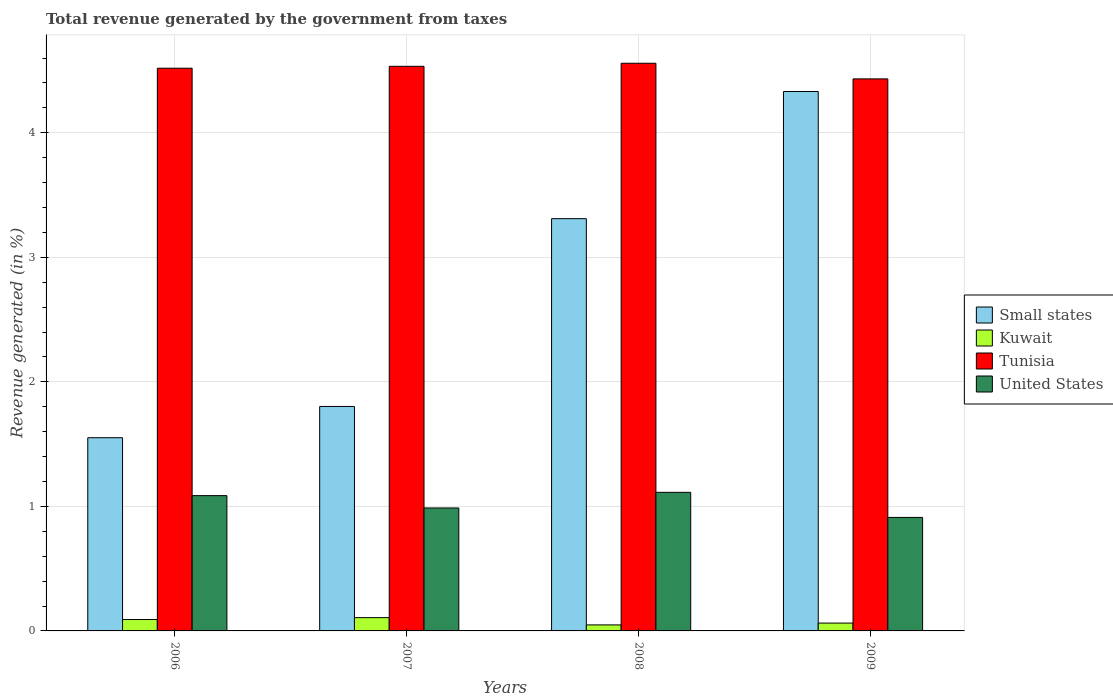How many different coloured bars are there?
Keep it short and to the point. 4. How many groups of bars are there?
Your response must be concise. 4. How many bars are there on the 4th tick from the left?
Your answer should be compact. 4. How many bars are there on the 4th tick from the right?
Give a very brief answer. 4. In how many cases, is the number of bars for a given year not equal to the number of legend labels?
Your answer should be compact. 0. What is the total revenue generated in Kuwait in 2007?
Your answer should be very brief. 0.11. Across all years, what is the maximum total revenue generated in Tunisia?
Make the answer very short. 4.56. Across all years, what is the minimum total revenue generated in United States?
Offer a very short reply. 0.91. In which year was the total revenue generated in Small states maximum?
Your answer should be very brief. 2009. In which year was the total revenue generated in Tunisia minimum?
Your answer should be compact. 2009. What is the total total revenue generated in Kuwait in the graph?
Make the answer very short. 0.31. What is the difference between the total revenue generated in Small states in 2006 and that in 2007?
Give a very brief answer. -0.25. What is the difference between the total revenue generated in Small states in 2007 and the total revenue generated in Kuwait in 2006?
Make the answer very short. 1.71. What is the average total revenue generated in Kuwait per year?
Give a very brief answer. 0.08. In the year 2008, what is the difference between the total revenue generated in Tunisia and total revenue generated in Kuwait?
Provide a succinct answer. 4.51. In how many years, is the total revenue generated in United States greater than 2.2 %?
Your response must be concise. 0. What is the ratio of the total revenue generated in United States in 2008 to that in 2009?
Give a very brief answer. 1.22. Is the total revenue generated in Small states in 2006 less than that in 2007?
Provide a short and direct response. Yes. What is the difference between the highest and the second highest total revenue generated in United States?
Keep it short and to the point. 0.03. What is the difference between the highest and the lowest total revenue generated in Tunisia?
Ensure brevity in your answer.  0.13. In how many years, is the total revenue generated in Tunisia greater than the average total revenue generated in Tunisia taken over all years?
Provide a succinct answer. 3. Is the sum of the total revenue generated in United States in 2007 and 2008 greater than the maximum total revenue generated in Small states across all years?
Your response must be concise. No. Is it the case that in every year, the sum of the total revenue generated in Kuwait and total revenue generated in United States is greater than the sum of total revenue generated in Small states and total revenue generated in Tunisia?
Give a very brief answer. Yes. What does the 3rd bar from the left in 2008 represents?
Your answer should be very brief. Tunisia. What does the 3rd bar from the right in 2007 represents?
Provide a short and direct response. Kuwait. How many bars are there?
Provide a succinct answer. 16. What is the difference between two consecutive major ticks on the Y-axis?
Your answer should be very brief. 1. Are the values on the major ticks of Y-axis written in scientific E-notation?
Offer a very short reply. No. How are the legend labels stacked?
Offer a terse response. Vertical. What is the title of the graph?
Ensure brevity in your answer.  Total revenue generated by the government from taxes. What is the label or title of the X-axis?
Give a very brief answer. Years. What is the label or title of the Y-axis?
Your answer should be very brief. Revenue generated (in %). What is the Revenue generated (in %) of Small states in 2006?
Keep it short and to the point. 1.55. What is the Revenue generated (in %) in Kuwait in 2006?
Your answer should be very brief. 0.09. What is the Revenue generated (in %) of Tunisia in 2006?
Your answer should be very brief. 4.52. What is the Revenue generated (in %) of United States in 2006?
Provide a succinct answer. 1.09. What is the Revenue generated (in %) in Small states in 2007?
Your answer should be very brief. 1.8. What is the Revenue generated (in %) of Kuwait in 2007?
Keep it short and to the point. 0.11. What is the Revenue generated (in %) in Tunisia in 2007?
Your answer should be compact. 4.53. What is the Revenue generated (in %) of United States in 2007?
Provide a short and direct response. 0.99. What is the Revenue generated (in %) in Small states in 2008?
Give a very brief answer. 3.31. What is the Revenue generated (in %) in Kuwait in 2008?
Make the answer very short. 0.05. What is the Revenue generated (in %) in Tunisia in 2008?
Offer a very short reply. 4.56. What is the Revenue generated (in %) in United States in 2008?
Offer a very short reply. 1.11. What is the Revenue generated (in %) of Small states in 2009?
Provide a short and direct response. 4.33. What is the Revenue generated (in %) in Kuwait in 2009?
Ensure brevity in your answer.  0.06. What is the Revenue generated (in %) of Tunisia in 2009?
Make the answer very short. 4.43. What is the Revenue generated (in %) in United States in 2009?
Provide a succinct answer. 0.91. Across all years, what is the maximum Revenue generated (in %) of Small states?
Your response must be concise. 4.33. Across all years, what is the maximum Revenue generated (in %) in Kuwait?
Keep it short and to the point. 0.11. Across all years, what is the maximum Revenue generated (in %) in Tunisia?
Your answer should be compact. 4.56. Across all years, what is the maximum Revenue generated (in %) in United States?
Ensure brevity in your answer.  1.11. Across all years, what is the minimum Revenue generated (in %) in Small states?
Offer a terse response. 1.55. Across all years, what is the minimum Revenue generated (in %) in Kuwait?
Your response must be concise. 0.05. Across all years, what is the minimum Revenue generated (in %) of Tunisia?
Ensure brevity in your answer.  4.43. Across all years, what is the minimum Revenue generated (in %) in United States?
Ensure brevity in your answer.  0.91. What is the total Revenue generated (in %) in Small states in the graph?
Provide a short and direct response. 10.99. What is the total Revenue generated (in %) in Kuwait in the graph?
Give a very brief answer. 0.31. What is the total Revenue generated (in %) in Tunisia in the graph?
Your answer should be very brief. 18.04. What is the total Revenue generated (in %) of United States in the graph?
Keep it short and to the point. 4.1. What is the difference between the Revenue generated (in %) of Small states in 2006 and that in 2007?
Ensure brevity in your answer.  -0.25. What is the difference between the Revenue generated (in %) in Kuwait in 2006 and that in 2007?
Give a very brief answer. -0.02. What is the difference between the Revenue generated (in %) of Tunisia in 2006 and that in 2007?
Your response must be concise. -0.02. What is the difference between the Revenue generated (in %) in United States in 2006 and that in 2007?
Offer a terse response. 0.1. What is the difference between the Revenue generated (in %) of Small states in 2006 and that in 2008?
Keep it short and to the point. -1.76. What is the difference between the Revenue generated (in %) of Kuwait in 2006 and that in 2008?
Ensure brevity in your answer.  0.04. What is the difference between the Revenue generated (in %) in Tunisia in 2006 and that in 2008?
Provide a short and direct response. -0.04. What is the difference between the Revenue generated (in %) of United States in 2006 and that in 2008?
Your response must be concise. -0.03. What is the difference between the Revenue generated (in %) in Small states in 2006 and that in 2009?
Offer a very short reply. -2.78. What is the difference between the Revenue generated (in %) of Kuwait in 2006 and that in 2009?
Your answer should be very brief. 0.03. What is the difference between the Revenue generated (in %) of Tunisia in 2006 and that in 2009?
Your response must be concise. 0.09. What is the difference between the Revenue generated (in %) in United States in 2006 and that in 2009?
Offer a very short reply. 0.17. What is the difference between the Revenue generated (in %) of Small states in 2007 and that in 2008?
Keep it short and to the point. -1.51. What is the difference between the Revenue generated (in %) of Kuwait in 2007 and that in 2008?
Ensure brevity in your answer.  0.06. What is the difference between the Revenue generated (in %) of Tunisia in 2007 and that in 2008?
Provide a short and direct response. -0.02. What is the difference between the Revenue generated (in %) of United States in 2007 and that in 2008?
Ensure brevity in your answer.  -0.13. What is the difference between the Revenue generated (in %) in Small states in 2007 and that in 2009?
Keep it short and to the point. -2.53. What is the difference between the Revenue generated (in %) in Kuwait in 2007 and that in 2009?
Keep it short and to the point. 0.04. What is the difference between the Revenue generated (in %) in Tunisia in 2007 and that in 2009?
Offer a very short reply. 0.1. What is the difference between the Revenue generated (in %) of United States in 2007 and that in 2009?
Offer a terse response. 0.08. What is the difference between the Revenue generated (in %) in Small states in 2008 and that in 2009?
Ensure brevity in your answer.  -1.02. What is the difference between the Revenue generated (in %) in Kuwait in 2008 and that in 2009?
Your response must be concise. -0.01. What is the difference between the Revenue generated (in %) in Tunisia in 2008 and that in 2009?
Provide a short and direct response. 0.13. What is the difference between the Revenue generated (in %) in United States in 2008 and that in 2009?
Provide a succinct answer. 0.2. What is the difference between the Revenue generated (in %) of Small states in 2006 and the Revenue generated (in %) of Kuwait in 2007?
Ensure brevity in your answer.  1.44. What is the difference between the Revenue generated (in %) in Small states in 2006 and the Revenue generated (in %) in Tunisia in 2007?
Your answer should be very brief. -2.98. What is the difference between the Revenue generated (in %) in Small states in 2006 and the Revenue generated (in %) in United States in 2007?
Provide a short and direct response. 0.56. What is the difference between the Revenue generated (in %) in Kuwait in 2006 and the Revenue generated (in %) in Tunisia in 2007?
Ensure brevity in your answer.  -4.44. What is the difference between the Revenue generated (in %) in Kuwait in 2006 and the Revenue generated (in %) in United States in 2007?
Your response must be concise. -0.9. What is the difference between the Revenue generated (in %) of Tunisia in 2006 and the Revenue generated (in %) of United States in 2007?
Offer a very short reply. 3.53. What is the difference between the Revenue generated (in %) in Small states in 2006 and the Revenue generated (in %) in Kuwait in 2008?
Give a very brief answer. 1.5. What is the difference between the Revenue generated (in %) of Small states in 2006 and the Revenue generated (in %) of Tunisia in 2008?
Provide a short and direct response. -3.01. What is the difference between the Revenue generated (in %) in Small states in 2006 and the Revenue generated (in %) in United States in 2008?
Ensure brevity in your answer.  0.44. What is the difference between the Revenue generated (in %) of Kuwait in 2006 and the Revenue generated (in %) of Tunisia in 2008?
Provide a succinct answer. -4.47. What is the difference between the Revenue generated (in %) in Kuwait in 2006 and the Revenue generated (in %) in United States in 2008?
Offer a very short reply. -1.02. What is the difference between the Revenue generated (in %) of Tunisia in 2006 and the Revenue generated (in %) of United States in 2008?
Provide a short and direct response. 3.41. What is the difference between the Revenue generated (in %) in Small states in 2006 and the Revenue generated (in %) in Kuwait in 2009?
Your answer should be compact. 1.49. What is the difference between the Revenue generated (in %) of Small states in 2006 and the Revenue generated (in %) of Tunisia in 2009?
Make the answer very short. -2.88. What is the difference between the Revenue generated (in %) in Small states in 2006 and the Revenue generated (in %) in United States in 2009?
Your answer should be compact. 0.64. What is the difference between the Revenue generated (in %) in Kuwait in 2006 and the Revenue generated (in %) in Tunisia in 2009?
Offer a very short reply. -4.34. What is the difference between the Revenue generated (in %) in Kuwait in 2006 and the Revenue generated (in %) in United States in 2009?
Your response must be concise. -0.82. What is the difference between the Revenue generated (in %) in Tunisia in 2006 and the Revenue generated (in %) in United States in 2009?
Give a very brief answer. 3.61. What is the difference between the Revenue generated (in %) in Small states in 2007 and the Revenue generated (in %) in Kuwait in 2008?
Your answer should be compact. 1.75. What is the difference between the Revenue generated (in %) in Small states in 2007 and the Revenue generated (in %) in Tunisia in 2008?
Your response must be concise. -2.76. What is the difference between the Revenue generated (in %) in Small states in 2007 and the Revenue generated (in %) in United States in 2008?
Your answer should be compact. 0.69. What is the difference between the Revenue generated (in %) of Kuwait in 2007 and the Revenue generated (in %) of Tunisia in 2008?
Your answer should be very brief. -4.45. What is the difference between the Revenue generated (in %) in Kuwait in 2007 and the Revenue generated (in %) in United States in 2008?
Ensure brevity in your answer.  -1.01. What is the difference between the Revenue generated (in %) of Tunisia in 2007 and the Revenue generated (in %) of United States in 2008?
Offer a very short reply. 3.42. What is the difference between the Revenue generated (in %) in Small states in 2007 and the Revenue generated (in %) in Kuwait in 2009?
Ensure brevity in your answer.  1.74. What is the difference between the Revenue generated (in %) of Small states in 2007 and the Revenue generated (in %) of Tunisia in 2009?
Your response must be concise. -2.63. What is the difference between the Revenue generated (in %) in Small states in 2007 and the Revenue generated (in %) in United States in 2009?
Your answer should be compact. 0.89. What is the difference between the Revenue generated (in %) of Kuwait in 2007 and the Revenue generated (in %) of Tunisia in 2009?
Provide a short and direct response. -4.33. What is the difference between the Revenue generated (in %) in Kuwait in 2007 and the Revenue generated (in %) in United States in 2009?
Provide a succinct answer. -0.8. What is the difference between the Revenue generated (in %) of Tunisia in 2007 and the Revenue generated (in %) of United States in 2009?
Your answer should be compact. 3.62. What is the difference between the Revenue generated (in %) in Small states in 2008 and the Revenue generated (in %) in Kuwait in 2009?
Offer a terse response. 3.25. What is the difference between the Revenue generated (in %) in Small states in 2008 and the Revenue generated (in %) in Tunisia in 2009?
Your response must be concise. -1.12. What is the difference between the Revenue generated (in %) of Small states in 2008 and the Revenue generated (in %) of United States in 2009?
Your answer should be very brief. 2.4. What is the difference between the Revenue generated (in %) in Kuwait in 2008 and the Revenue generated (in %) in Tunisia in 2009?
Your response must be concise. -4.38. What is the difference between the Revenue generated (in %) in Kuwait in 2008 and the Revenue generated (in %) in United States in 2009?
Offer a terse response. -0.86. What is the difference between the Revenue generated (in %) in Tunisia in 2008 and the Revenue generated (in %) in United States in 2009?
Give a very brief answer. 3.65. What is the average Revenue generated (in %) of Small states per year?
Your answer should be compact. 2.75. What is the average Revenue generated (in %) in Kuwait per year?
Ensure brevity in your answer.  0.08. What is the average Revenue generated (in %) in Tunisia per year?
Your answer should be compact. 4.51. What is the average Revenue generated (in %) in United States per year?
Offer a terse response. 1.02. In the year 2006, what is the difference between the Revenue generated (in %) of Small states and Revenue generated (in %) of Kuwait?
Your answer should be compact. 1.46. In the year 2006, what is the difference between the Revenue generated (in %) of Small states and Revenue generated (in %) of Tunisia?
Provide a short and direct response. -2.97. In the year 2006, what is the difference between the Revenue generated (in %) in Small states and Revenue generated (in %) in United States?
Ensure brevity in your answer.  0.47. In the year 2006, what is the difference between the Revenue generated (in %) of Kuwait and Revenue generated (in %) of Tunisia?
Provide a succinct answer. -4.43. In the year 2006, what is the difference between the Revenue generated (in %) of Kuwait and Revenue generated (in %) of United States?
Your response must be concise. -0.99. In the year 2006, what is the difference between the Revenue generated (in %) of Tunisia and Revenue generated (in %) of United States?
Give a very brief answer. 3.43. In the year 2007, what is the difference between the Revenue generated (in %) of Small states and Revenue generated (in %) of Kuwait?
Ensure brevity in your answer.  1.7. In the year 2007, what is the difference between the Revenue generated (in %) of Small states and Revenue generated (in %) of Tunisia?
Provide a succinct answer. -2.73. In the year 2007, what is the difference between the Revenue generated (in %) of Small states and Revenue generated (in %) of United States?
Provide a short and direct response. 0.81. In the year 2007, what is the difference between the Revenue generated (in %) in Kuwait and Revenue generated (in %) in Tunisia?
Your response must be concise. -4.43. In the year 2007, what is the difference between the Revenue generated (in %) of Kuwait and Revenue generated (in %) of United States?
Make the answer very short. -0.88. In the year 2007, what is the difference between the Revenue generated (in %) in Tunisia and Revenue generated (in %) in United States?
Your response must be concise. 3.55. In the year 2008, what is the difference between the Revenue generated (in %) of Small states and Revenue generated (in %) of Kuwait?
Provide a succinct answer. 3.26. In the year 2008, what is the difference between the Revenue generated (in %) in Small states and Revenue generated (in %) in Tunisia?
Your response must be concise. -1.25. In the year 2008, what is the difference between the Revenue generated (in %) of Small states and Revenue generated (in %) of United States?
Offer a very short reply. 2.2. In the year 2008, what is the difference between the Revenue generated (in %) of Kuwait and Revenue generated (in %) of Tunisia?
Offer a very short reply. -4.51. In the year 2008, what is the difference between the Revenue generated (in %) of Kuwait and Revenue generated (in %) of United States?
Your response must be concise. -1.06. In the year 2008, what is the difference between the Revenue generated (in %) in Tunisia and Revenue generated (in %) in United States?
Make the answer very short. 3.45. In the year 2009, what is the difference between the Revenue generated (in %) in Small states and Revenue generated (in %) in Kuwait?
Your answer should be compact. 4.27. In the year 2009, what is the difference between the Revenue generated (in %) of Small states and Revenue generated (in %) of Tunisia?
Offer a terse response. -0.1. In the year 2009, what is the difference between the Revenue generated (in %) in Small states and Revenue generated (in %) in United States?
Offer a terse response. 3.42. In the year 2009, what is the difference between the Revenue generated (in %) in Kuwait and Revenue generated (in %) in Tunisia?
Offer a very short reply. -4.37. In the year 2009, what is the difference between the Revenue generated (in %) of Kuwait and Revenue generated (in %) of United States?
Your answer should be very brief. -0.85. In the year 2009, what is the difference between the Revenue generated (in %) in Tunisia and Revenue generated (in %) in United States?
Your response must be concise. 3.52. What is the ratio of the Revenue generated (in %) in Small states in 2006 to that in 2007?
Offer a very short reply. 0.86. What is the ratio of the Revenue generated (in %) of Kuwait in 2006 to that in 2007?
Your answer should be compact. 0.86. What is the ratio of the Revenue generated (in %) of United States in 2006 to that in 2007?
Offer a very short reply. 1.1. What is the ratio of the Revenue generated (in %) of Small states in 2006 to that in 2008?
Offer a very short reply. 0.47. What is the ratio of the Revenue generated (in %) in Kuwait in 2006 to that in 2008?
Provide a short and direct response. 1.9. What is the ratio of the Revenue generated (in %) in Tunisia in 2006 to that in 2008?
Make the answer very short. 0.99. What is the ratio of the Revenue generated (in %) in United States in 2006 to that in 2008?
Make the answer very short. 0.98. What is the ratio of the Revenue generated (in %) in Small states in 2006 to that in 2009?
Offer a very short reply. 0.36. What is the ratio of the Revenue generated (in %) in Kuwait in 2006 to that in 2009?
Your response must be concise. 1.45. What is the ratio of the Revenue generated (in %) of Tunisia in 2006 to that in 2009?
Your answer should be very brief. 1.02. What is the ratio of the Revenue generated (in %) of United States in 2006 to that in 2009?
Offer a very short reply. 1.19. What is the ratio of the Revenue generated (in %) in Small states in 2007 to that in 2008?
Keep it short and to the point. 0.54. What is the ratio of the Revenue generated (in %) in Kuwait in 2007 to that in 2008?
Your response must be concise. 2.21. What is the ratio of the Revenue generated (in %) in Tunisia in 2007 to that in 2008?
Ensure brevity in your answer.  0.99. What is the ratio of the Revenue generated (in %) of United States in 2007 to that in 2008?
Give a very brief answer. 0.89. What is the ratio of the Revenue generated (in %) in Small states in 2007 to that in 2009?
Your answer should be very brief. 0.42. What is the ratio of the Revenue generated (in %) of Kuwait in 2007 to that in 2009?
Offer a very short reply. 1.69. What is the ratio of the Revenue generated (in %) of Tunisia in 2007 to that in 2009?
Provide a succinct answer. 1.02. What is the ratio of the Revenue generated (in %) of United States in 2007 to that in 2009?
Offer a very short reply. 1.08. What is the ratio of the Revenue generated (in %) of Small states in 2008 to that in 2009?
Your answer should be very brief. 0.76. What is the ratio of the Revenue generated (in %) in Kuwait in 2008 to that in 2009?
Your answer should be compact. 0.77. What is the ratio of the Revenue generated (in %) of Tunisia in 2008 to that in 2009?
Give a very brief answer. 1.03. What is the ratio of the Revenue generated (in %) in United States in 2008 to that in 2009?
Your answer should be very brief. 1.22. What is the difference between the highest and the second highest Revenue generated (in %) of Small states?
Give a very brief answer. 1.02. What is the difference between the highest and the second highest Revenue generated (in %) of Kuwait?
Provide a succinct answer. 0.02. What is the difference between the highest and the second highest Revenue generated (in %) in Tunisia?
Give a very brief answer. 0.02. What is the difference between the highest and the second highest Revenue generated (in %) of United States?
Your answer should be very brief. 0.03. What is the difference between the highest and the lowest Revenue generated (in %) of Small states?
Provide a short and direct response. 2.78. What is the difference between the highest and the lowest Revenue generated (in %) of Kuwait?
Provide a short and direct response. 0.06. What is the difference between the highest and the lowest Revenue generated (in %) of Tunisia?
Provide a short and direct response. 0.13. What is the difference between the highest and the lowest Revenue generated (in %) in United States?
Give a very brief answer. 0.2. 